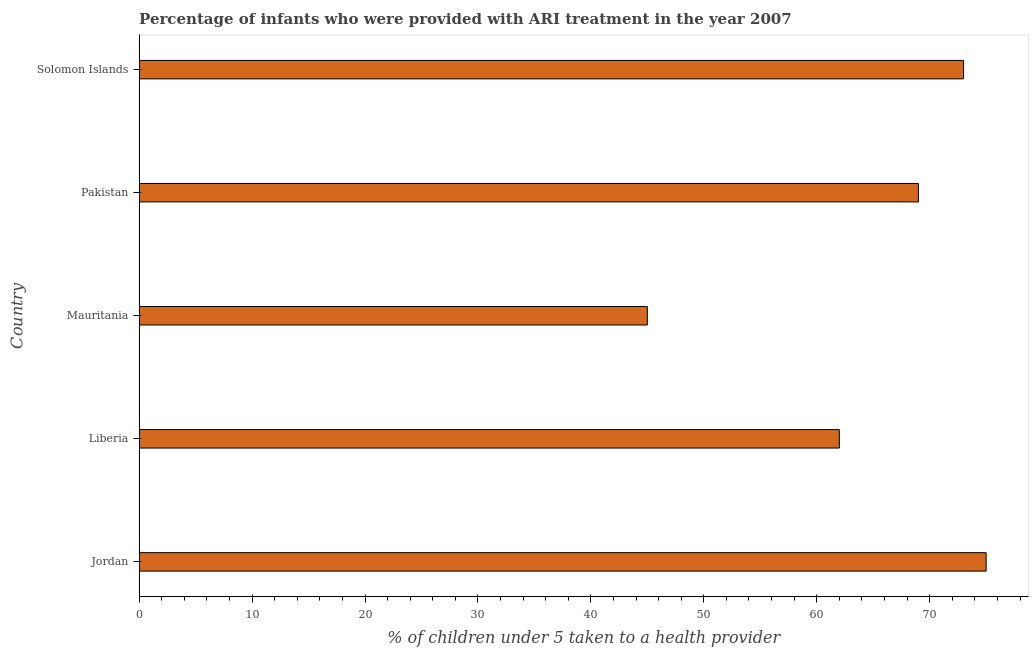Does the graph contain any zero values?
Your response must be concise. No. Does the graph contain grids?
Offer a very short reply. No. What is the title of the graph?
Ensure brevity in your answer.  Percentage of infants who were provided with ARI treatment in the year 2007. What is the label or title of the X-axis?
Offer a terse response. % of children under 5 taken to a health provider. Across all countries, what is the maximum percentage of children who were provided with ari treatment?
Offer a very short reply. 75. Across all countries, what is the minimum percentage of children who were provided with ari treatment?
Your response must be concise. 45. In which country was the percentage of children who were provided with ari treatment maximum?
Provide a succinct answer. Jordan. In which country was the percentage of children who were provided with ari treatment minimum?
Offer a very short reply. Mauritania. What is the sum of the percentage of children who were provided with ari treatment?
Your answer should be very brief. 324. What is the difference between the percentage of children who were provided with ari treatment in Liberia and Pakistan?
Your answer should be very brief. -7. What is the average percentage of children who were provided with ari treatment per country?
Provide a short and direct response. 64.8. What is the ratio of the percentage of children who were provided with ari treatment in Jordan to that in Pakistan?
Provide a succinct answer. 1.09. Is the percentage of children who were provided with ari treatment in Jordan less than that in Pakistan?
Offer a terse response. No. Is the difference between the percentage of children who were provided with ari treatment in Mauritania and Solomon Islands greater than the difference between any two countries?
Your answer should be very brief. No. Is the sum of the percentage of children who were provided with ari treatment in Jordan and Liberia greater than the maximum percentage of children who were provided with ari treatment across all countries?
Provide a short and direct response. Yes. How many bars are there?
Give a very brief answer. 5. Are all the bars in the graph horizontal?
Ensure brevity in your answer.  Yes. Are the values on the major ticks of X-axis written in scientific E-notation?
Give a very brief answer. No. What is the % of children under 5 taken to a health provider of Mauritania?
Provide a succinct answer. 45. What is the % of children under 5 taken to a health provider in Solomon Islands?
Ensure brevity in your answer.  73. What is the difference between the % of children under 5 taken to a health provider in Jordan and Solomon Islands?
Provide a short and direct response. 2. What is the difference between the % of children under 5 taken to a health provider in Liberia and Solomon Islands?
Offer a very short reply. -11. What is the ratio of the % of children under 5 taken to a health provider in Jordan to that in Liberia?
Give a very brief answer. 1.21. What is the ratio of the % of children under 5 taken to a health provider in Jordan to that in Mauritania?
Ensure brevity in your answer.  1.67. What is the ratio of the % of children under 5 taken to a health provider in Jordan to that in Pakistan?
Your answer should be very brief. 1.09. What is the ratio of the % of children under 5 taken to a health provider in Liberia to that in Mauritania?
Provide a short and direct response. 1.38. What is the ratio of the % of children under 5 taken to a health provider in Liberia to that in Pakistan?
Keep it short and to the point. 0.9. What is the ratio of the % of children under 5 taken to a health provider in Liberia to that in Solomon Islands?
Provide a short and direct response. 0.85. What is the ratio of the % of children under 5 taken to a health provider in Mauritania to that in Pakistan?
Ensure brevity in your answer.  0.65. What is the ratio of the % of children under 5 taken to a health provider in Mauritania to that in Solomon Islands?
Keep it short and to the point. 0.62. What is the ratio of the % of children under 5 taken to a health provider in Pakistan to that in Solomon Islands?
Your answer should be very brief. 0.94. 